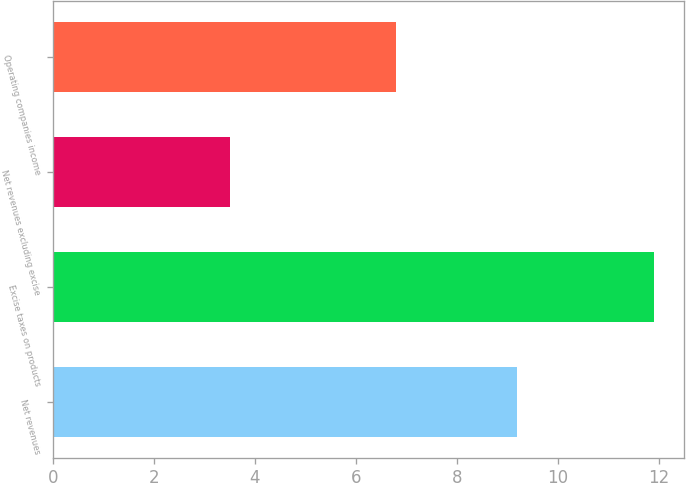Convert chart. <chart><loc_0><loc_0><loc_500><loc_500><bar_chart><fcel>Net revenues<fcel>Excise taxes on products<fcel>Net revenues excluding excise<fcel>Operating companies income<nl><fcel>9.2<fcel>11.9<fcel>3.5<fcel>6.8<nl></chart> 